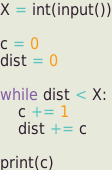<code> <loc_0><loc_0><loc_500><loc_500><_Python_>X = int(input())

c = 0
dist = 0

while dist < X:
    c += 1
    dist += c

print(c)</code> 